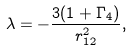<formula> <loc_0><loc_0><loc_500><loc_500>\lambda = - \frac { 3 ( 1 + \Gamma _ { 4 } ) } { r _ { 1 2 } ^ { 2 } } ,</formula> 